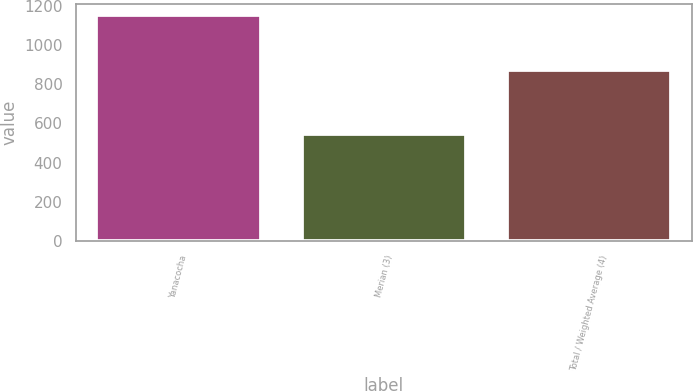Convert chart to OTSL. <chart><loc_0><loc_0><loc_500><loc_500><bar_chart><fcel>Yanacocha<fcel>Merian (3)<fcel>Total / Weighted Average (4)<nl><fcel>1150<fcel>544<fcel>870<nl></chart> 